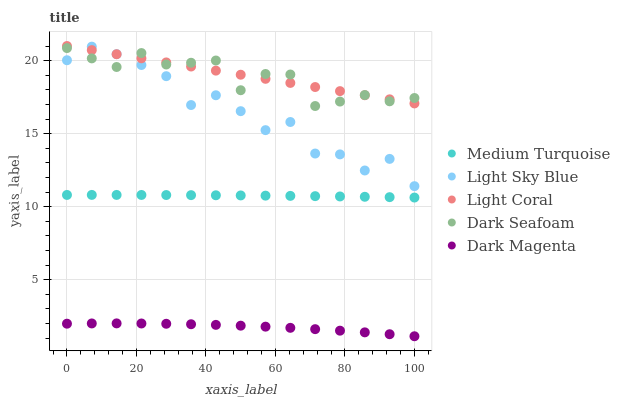Does Dark Magenta have the minimum area under the curve?
Answer yes or no. Yes. Does Light Coral have the maximum area under the curve?
Answer yes or no. Yes. Does Dark Seafoam have the minimum area under the curve?
Answer yes or no. No. Does Dark Seafoam have the maximum area under the curve?
Answer yes or no. No. Is Light Coral the smoothest?
Answer yes or no. Yes. Is Light Sky Blue the roughest?
Answer yes or no. Yes. Is Dark Seafoam the smoothest?
Answer yes or no. No. Is Dark Seafoam the roughest?
Answer yes or no. No. Does Dark Magenta have the lowest value?
Answer yes or no. Yes. Does Dark Seafoam have the lowest value?
Answer yes or no. No. Does Light Coral have the highest value?
Answer yes or no. Yes. Does Dark Seafoam have the highest value?
Answer yes or no. No. Is Dark Magenta less than Medium Turquoise?
Answer yes or no. Yes. Is Light Coral greater than Medium Turquoise?
Answer yes or no. Yes. Does Dark Seafoam intersect Light Sky Blue?
Answer yes or no. Yes. Is Dark Seafoam less than Light Sky Blue?
Answer yes or no. No. Is Dark Seafoam greater than Light Sky Blue?
Answer yes or no. No. Does Dark Magenta intersect Medium Turquoise?
Answer yes or no. No. 